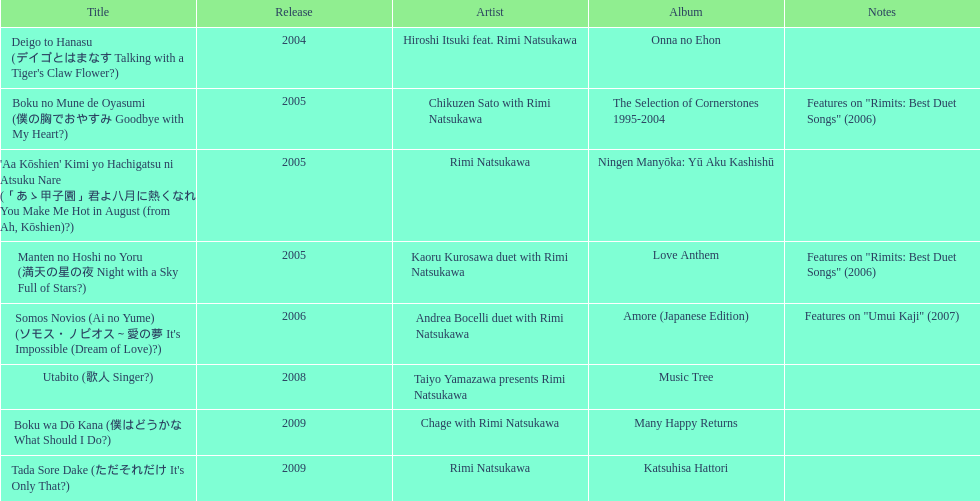What is the most recent title launched? 2009. 